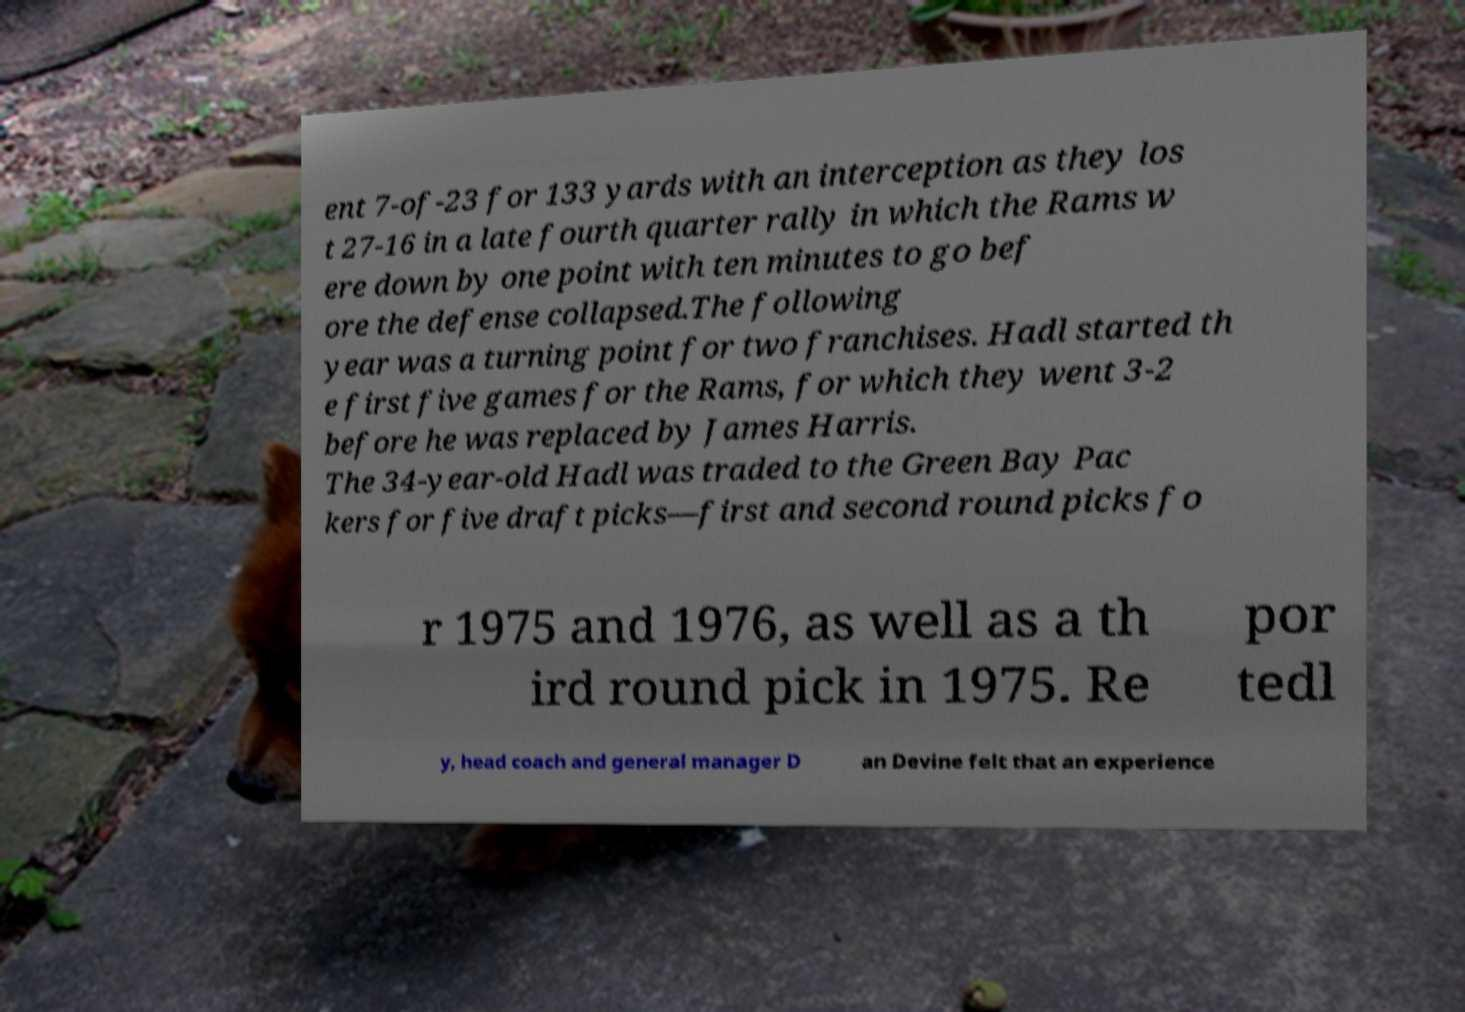For documentation purposes, I need the text within this image transcribed. Could you provide that? ent 7-of-23 for 133 yards with an interception as they los t 27-16 in a late fourth quarter rally in which the Rams w ere down by one point with ten minutes to go bef ore the defense collapsed.The following year was a turning point for two franchises. Hadl started th e first five games for the Rams, for which they went 3-2 before he was replaced by James Harris. The 34-year-old Hadl was traded to the Green Bay Pac kers for five draft picks—first and second round picks fo r 1975 and 1976, as well as a th ird round pick in 1975. Re por tedl y, head coach and general manager D an Devine felt that an experience 